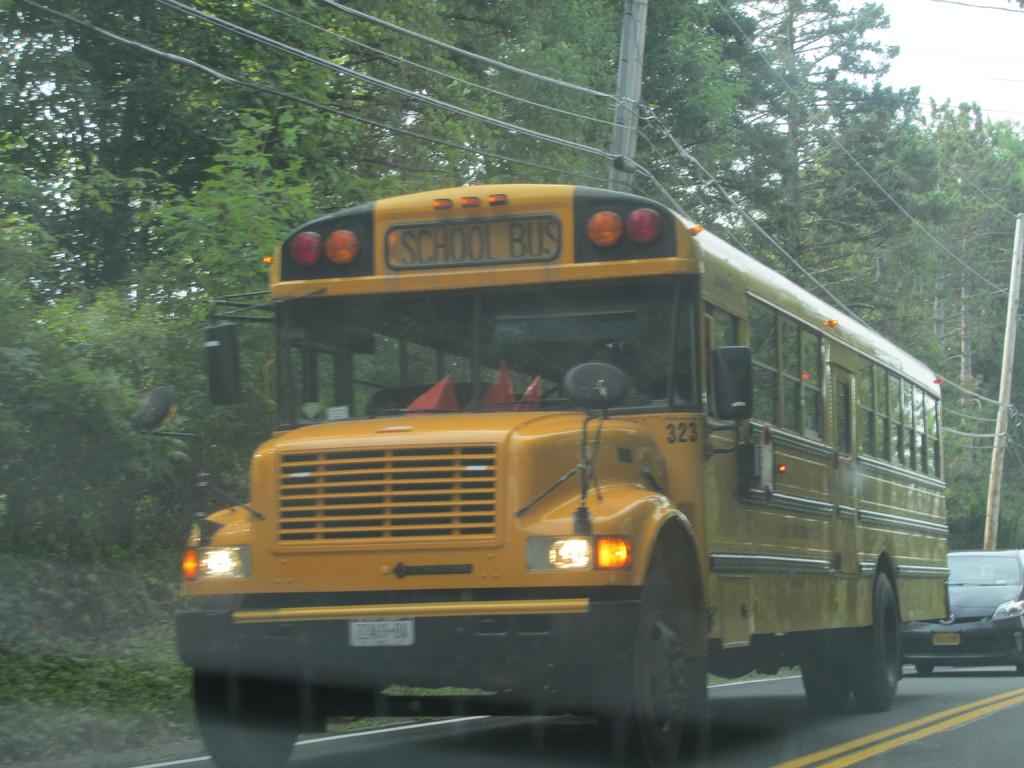<image>
Render a clear and concise summary of the photo. A yellow bus with the words School Bus on the top 